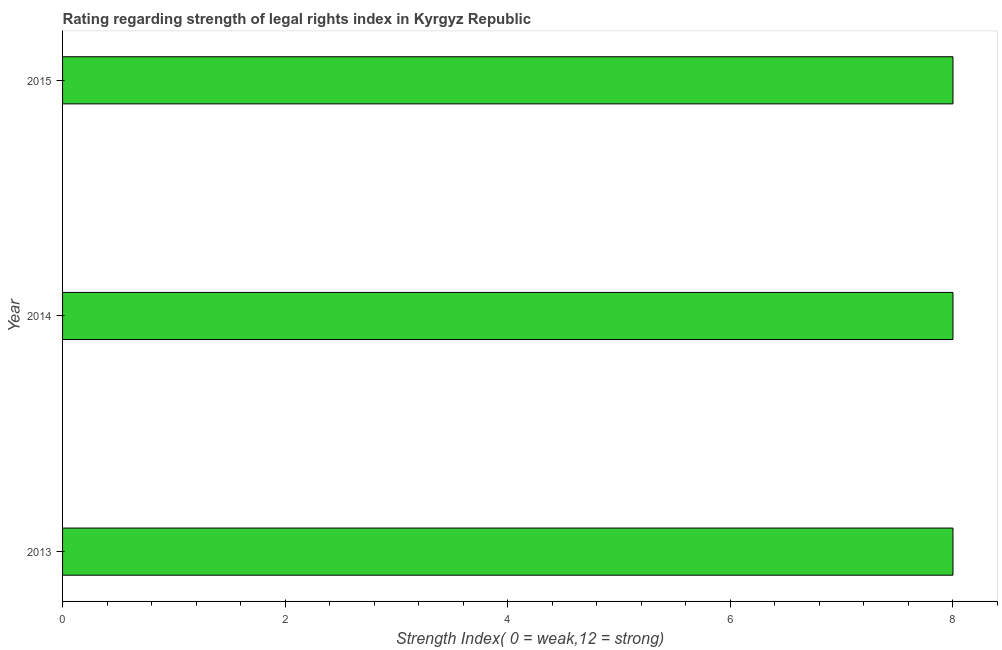Does the graph contain grids?
Offer a terse response. No. What is the title of the graph?
Provide a short and direct response. Rating regarding strength of legal rights index in Kyrgyz Republic. What is the label or title of the X-axis?
Offer a very short reply. Strength Index( 0 = weak,12 = strong). In which year was the strength of legal rights index minimum?
Provide a short and direct response. 2013. What is the sum of the strength of legal rights index?
Keep it short and to the point. 24. What is the average strength of legal rights index per year?
Offer a terse response. 8. What is the median strength of legal rights index?
Your answer should be very brief. 8. Is the strength of legal rights index in 2013 less than that in 2014?
Provide a succinct answer. No. Is the difference between the strength of legal rights index in 2014 and 2015 greater than the difference between any two years?
Give a very brief answer. Yes. What is the difference between the highest and the second highest strength of legal rights index?
Give a very brief answer. 0. Is the sum of the strength of legal rights index in 2013 and 2015 greater than the maximum strength of legal rights index across all years?
Offer a very short reply. Yes. What is the difference between the highest and the lowest strength of legal rights index?
Your answer should be compact. 0. How many bars are there?
Your answer should be very brief. 3. Are all the bars in the graph horizontal?
Give a very brief answer. Yes. How many years are there in the graph?
Your response must be concise. 3. What is the difference between two consecutive major ticks on the X-axis?
Your response must be concise. 2. What is the Strength Index( 0 = weak,12 = strong) of 2013?
Make the answer very short. 8. What is the Strength Index( 0 = weak,12 = strong) in 2015?
Give a very brief answer. 8. What is the difference between the Strength Index( 0 = weak,12 = strong) in 2013 and 2015?
Offer a very short reply. 0. What is the difference between the Strength Index( 0 = weak,12 = strong) in 2014 and 2015?
Give a very brief answer. 0. What is the ratio of the Strength Index( 0 = weak,12 = strong) in 2013 to that in 2014?
Offer a very short reply. 1. What is the ratio of the Strength Index( 0 = weak,12 = strong) in 2013 to that in 2015?
Give a very brief answer. 1. 